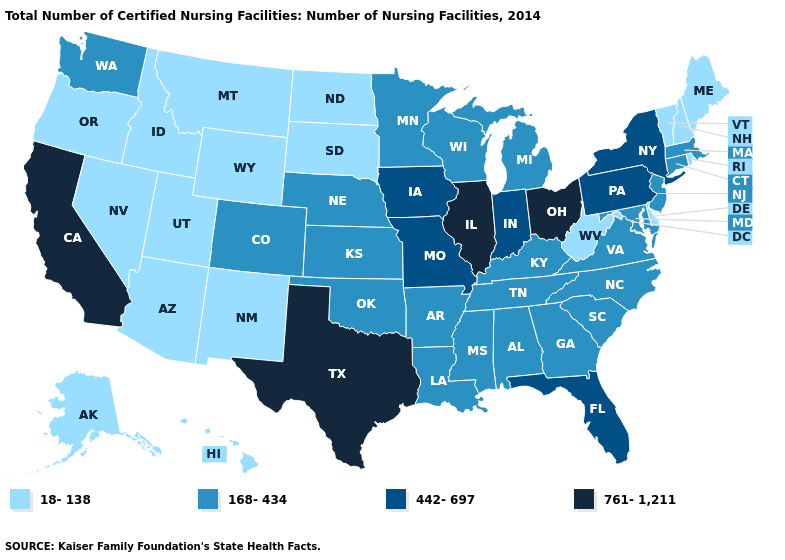Among the states that border North Dakota , does Minnesota have the lowest value?
Quick response, please. No. Among the states that border Iowa , does South Dakota have the lowest value?
Write a very short answer. Yes. Does New Hampshire have the same value as California?
Give a very brief answer. No. How many symbols are there in the legend?
Give a very brief answer. 4. Among the states that border Colorado , which have the highest value?
Answer briefly. Kansas, Nebraska, Oklahoma. Among the states that border Washington , which have the highest value?
Write a very short answer. Idaho, Oregon. Does Illinois have the highest value in the MidWest?
Short answer required. Yes. Which states have the lowest value in the Northeast?
Quick response, please. Maine, New Hampshire, Rhode Island, Vermont. Does Ohio have the highest value in the USA?
Give a very brief answer. Yes. What is the value of West Virginia?
Be succinct. 18-138. Among the states that border West Virginia , which have the highest value?
Answer briefly. Ohio. Among the states that border Iowa , which have the lowest value?
Concise answer only. South Dakota. Does the map have missing data?
Give a very brief answer. No. Name the states that have a value in the range 442-697?
Concise answer only. Florida, Indiana, Iowa, Missouri, New York, Pennsylvania. What is the value of Tennessee?
Concise answer only. 168-434. 